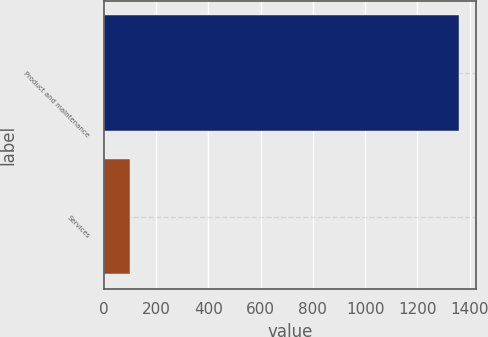Convert chart. <chart><loc_0><loc_0><loc_500><loc_500><bar_chart><fcel>Product and maintenance<fcel>Services<nl><fcel>1357.9<fcel>102.2<nl></chart> 